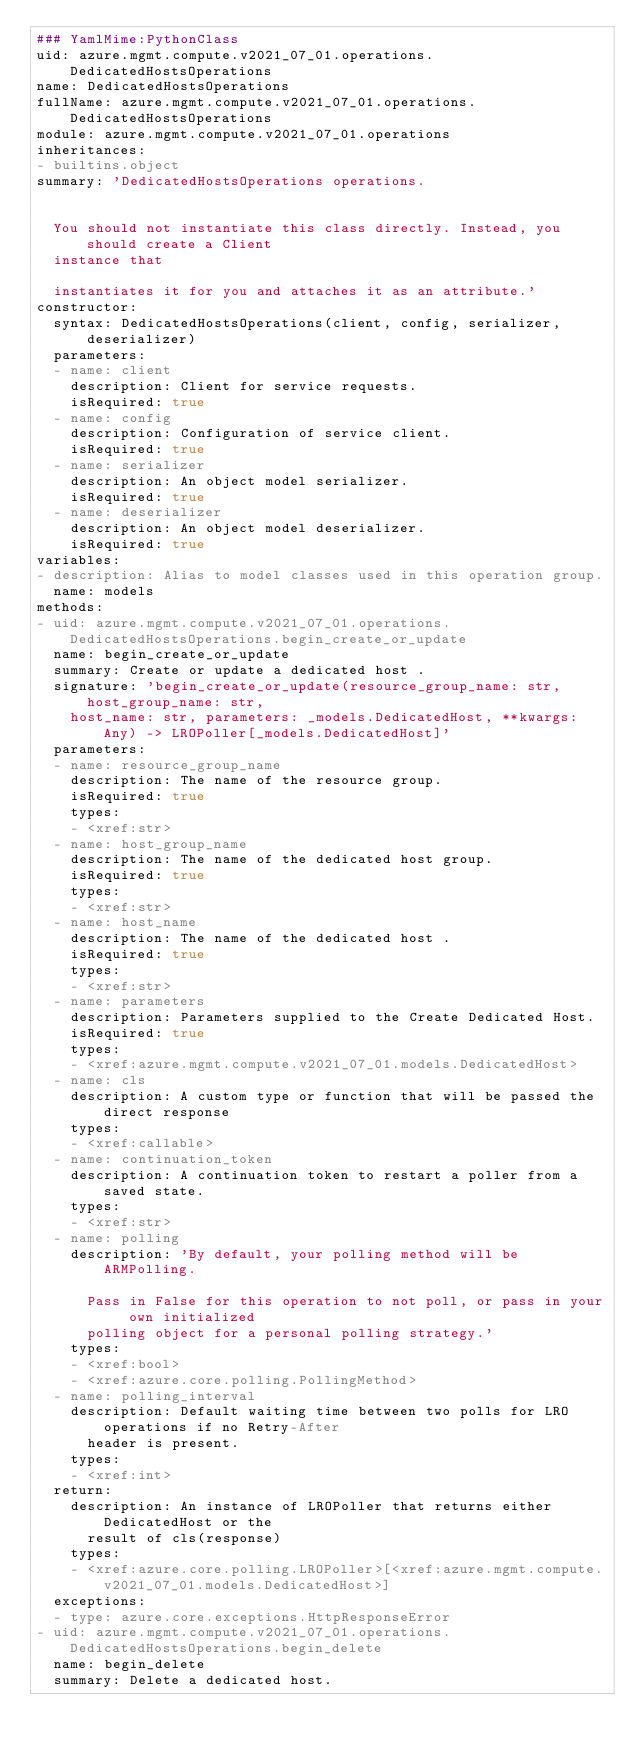Convert code to text. <code><loc_0><loc_0><loc_500><loc_500><_YAML_>### YamlMime:PythonClass
uid: azure.mgmt.compute.v2021_07_01.operations.DedicatedHostsOperations
name: DedicatedHostsOperations
fullName: azure.mgmt.compute.v2021_07_01.operations.DedicatedHostsOperations
module: azure.mgmt.compute.v2021_07_01.operations
inheritances:
- builtins.object
summary: 'DedicatedHostsOperations operations.


  You should not instantiate this class directly. Instead, you should create a Client
  instance that

  instantiates it for you and attaches it as an attribute.'
constructor:
  syntax: DedicatedHostsOperations(client, config, serializer, deserializer)
  parameters:
  - name: client
    description: Client for service requests.
    isRequired: true
  - name: config
    description: Configuration of service client.
    isRequired: true
  - name: serializer
    description: An object model serializer.
    isRequired: true
  - name: deserializer
    description: An object model deserializer.
    isRequired: true
variables:
- description: Alias to model classes used in this operation group.
  name: models
methods:
- uid: azure.mgmt.compute.v2021_07_01.operations.DedicatedHostsOperations.begin_create_or_update
  name: begin_create_or_update
  summary: Create or update a dedicated host .
  signature: 'begin_create_or_update(resource_group_name: str, host_group_name: str,
    host_name: str, parameters: _models.DedicatedHost, **kwargs: Any) -> LROPoller[_models.DedicatedHost]'
  parameters:
  - name: resource_group_name
    description: The name of the resource group.
    isRequired: true
    types:
    - <xref:str>
  - name: host_group_name
    description: The name of the dedicated host group.
    isRequired: true
    types:
    - <xref:str>
  - name: host_name
    description: The name of the dedicated host .
    isRequired: true
    types:
    - <xref:str>
  - name: parameters
    description: Parameters supplied to the Create Dedicated Host.
    isRequired: true
    types:
    - <xref:azure.mgmt.compute.v2021_07_01.models.DedicatedHost>
  - name: cls
    description: A custom type or function that will be passed the direct response
    types:
    - <xref:callable>
  - name: continuation_token
    description: A continuation token to restart a poller from a saved state.
    types:
    - <xref:str>
  - name: polling
    description: 'By default, your polling method will be ARMPolling.

      Pass in False for this operation to not poll, or pass in your own initialized
      polling object for a personal polling strategy.'
    types:
    - <xref:bool>
    - <xref:azure.core.polling.PollingMethod>
  - name: polling_interval
    description: Default waiting time between two polls for LRO operations if no Retry-After
      header is present.
    types:
    - <xref:int>
  return:
    description: An instance of LROPoller that returns either DedicatedHost or the
      result of cls(response)
    types:
    - <xref:azure.core.polling.LROPoller>[<xref:azure.mgmt.compute.v2021_07_01.models.DedicatedHost>]
  exceptions:
  - type: azure.core.exceptions.HttpResponseError
- uid: azure.mgmt.compute.v2021_07_01.operations.DedicatedHostsOperations.begin_delete
  name: begin_delete
  summary: Delete a dedicated host.</code> 